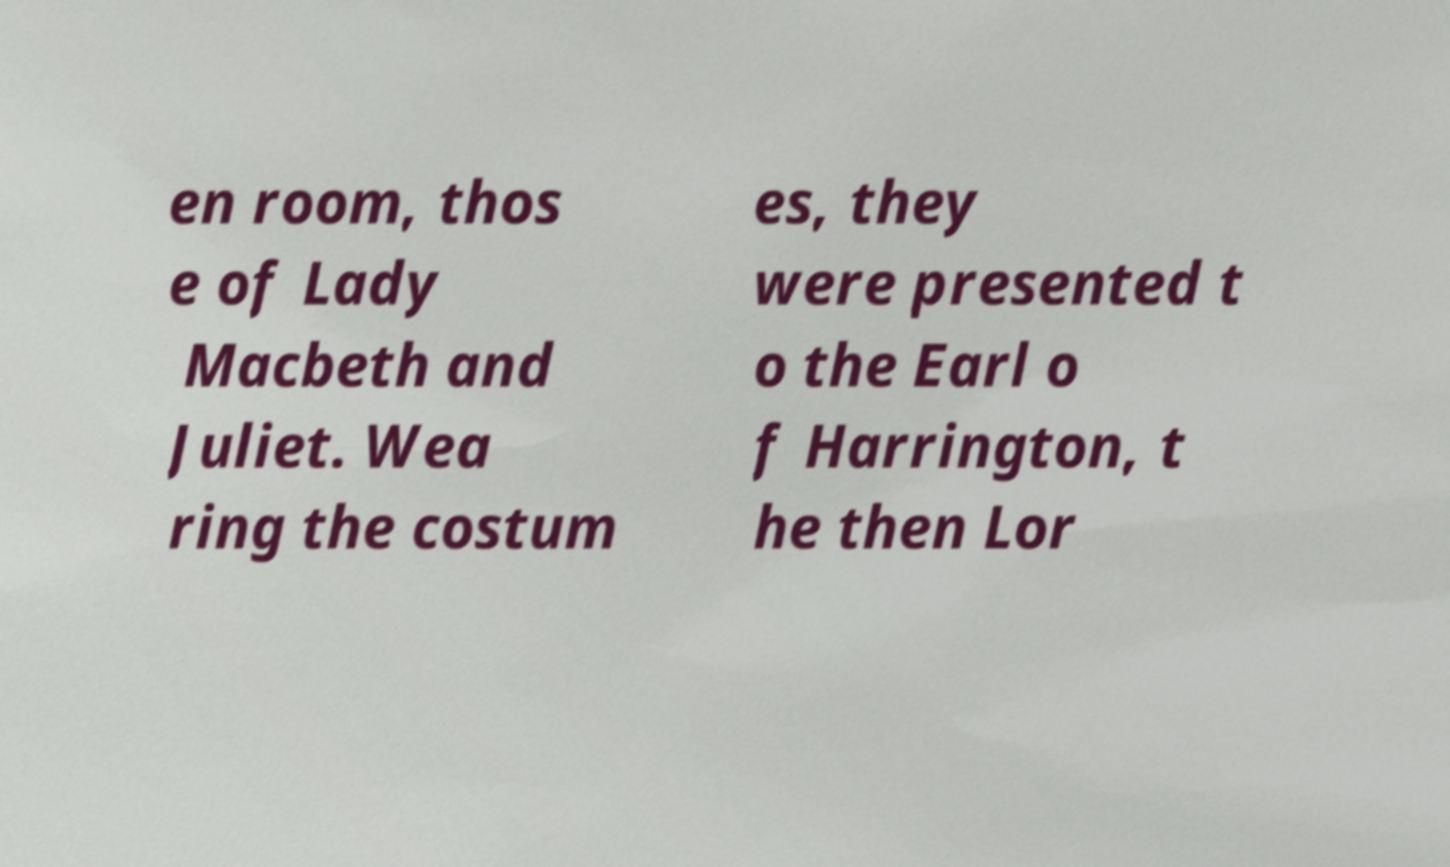Please identify and transcribe the text found in this image. en room, thos e of Lady Macbeth and Juliet. Wea ring the costum es, they were presented t o the Earl o f Harrington, t he then Lor 